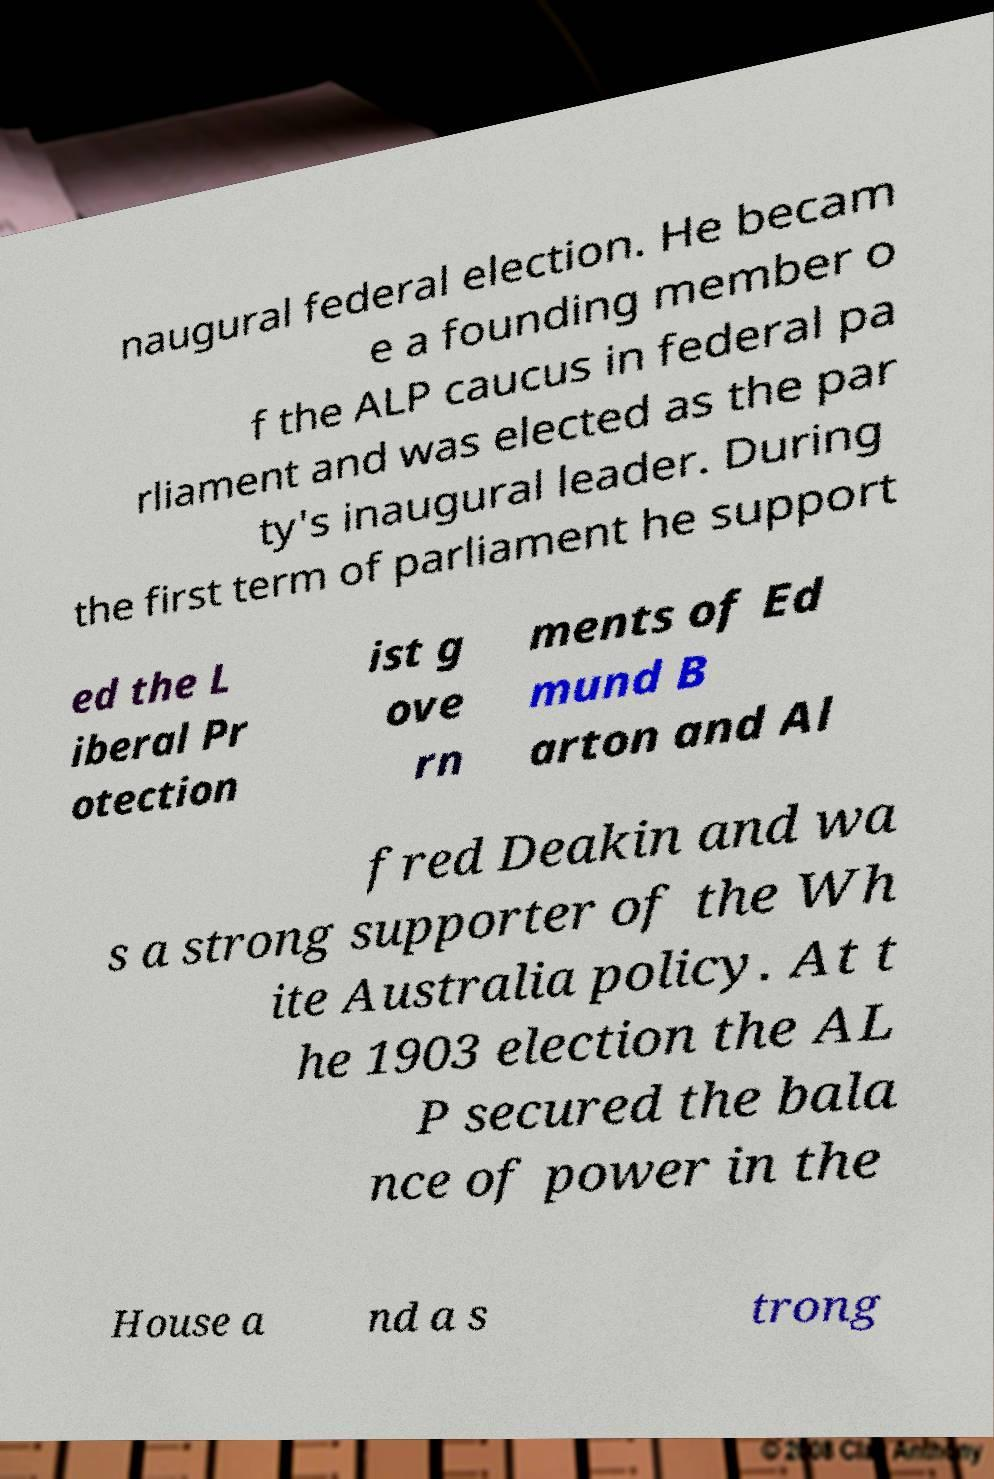Please identify and transcribe the text found in this image. naugural federal election. He becam e a founding member o f the ALP caucus in federal pa rliament and was elected as the par ty's inaugural leader. During the first term of parliament he support ed the L iberal Pr otection ist g ove rn ments of Ed mund B arton and Al fred Deakin and wa s a strong supporter of the Wh ite Australia policy. At t he 1903 election the AL P secured the bala nce of power in the House a nd a s trong 